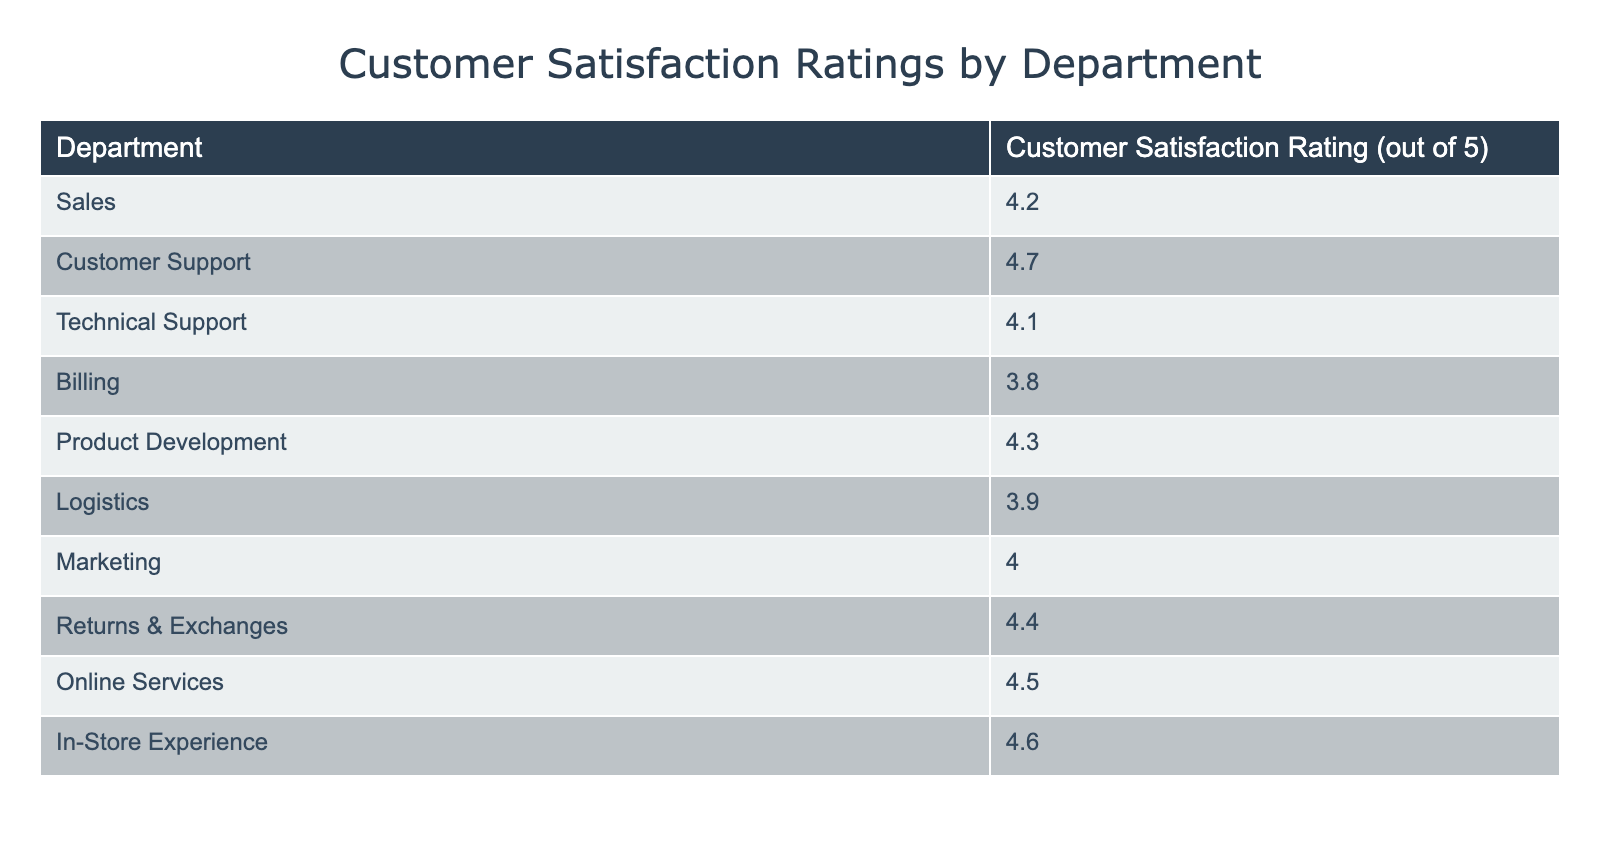What is the customer satisfaction rating for the Customer Support department? The table lists the Customer Satisfaction Ratings for various departments, and for Customer Support, it specifically states that the rating is 4.7 out of 5.
Answer: 4.7 Which department has the lowest customer satisfaction rating? To determine the department with the lowest rating, I scanned through the listed ratings and found that Billing has the lowest rating of 3.8 out of 5.
Answer: Billing What is the average customer satisfaction rating across all departments? First, I sum the ratings: (4.2 + 4.7 + 4.1 + 3.8 + 4.3 + 3.9 + 4.0 + 4.4 + 4.5 + 4.6) = 43.5. Since there are 10 departments, I divide 43.5 by 10, yielding an average of 4.35.
Answer: 4.35 Is the customer satisfaction rating for Technical Support higher than that for Billing? The rating for Technical Support is 4.1, while for Billing it is 3.8. Since 4.1 is greater than 3.8, the statement is true.
Answer: Yes How many departments have a customer satisfaction rating over 4.5? I review the ratings and note that Online Services (4.5), In-Store Experience (4.6), Customer Support (4.7), and Returns & Exchanges (4.4) have ratings above 4.5. Thus, there are 4 departments meeting this criterion.
Answer: 4 Which department is the most satisfied based on customer ratings? To find the department with the highest rating, I look at the table and see that Customer Support has the highest rating of 4.7 out of 5.
Answer: Customer Support What is the difference between the highest and lowest customer satisfaction ratings? The highest rating is 4.7 (Customer Support) and the lowest is 3.8 (Billing). The difference is calculated as 4.7 - 3.8 = 0.9.
Answer: 0.9 Are there more departments with a rating of 4.0 or less than those with a rating above 4.0? I check the ratings: The departments with 4.0 or less are Billing (3.8), Logistics (3.9), and Technical Support (4.1), which totals to 3 departments. Those above 4.0 are Sales, Customer Support, Product Development, Marketing, Returns & Exchanges, Online Services, and In-Store Experience, totaling 7 departments. Therefore, there are more departments with a rating above 4.0.
Answer: Yes What is the combined customer satisfaction rating of the Sales and Marketing departments? I find the ratings: Sales is at 4.2 and Marketing is at 4.0. Adding these together yields 4.2 + 4.0 = 8.2.
Answer: 8.2 